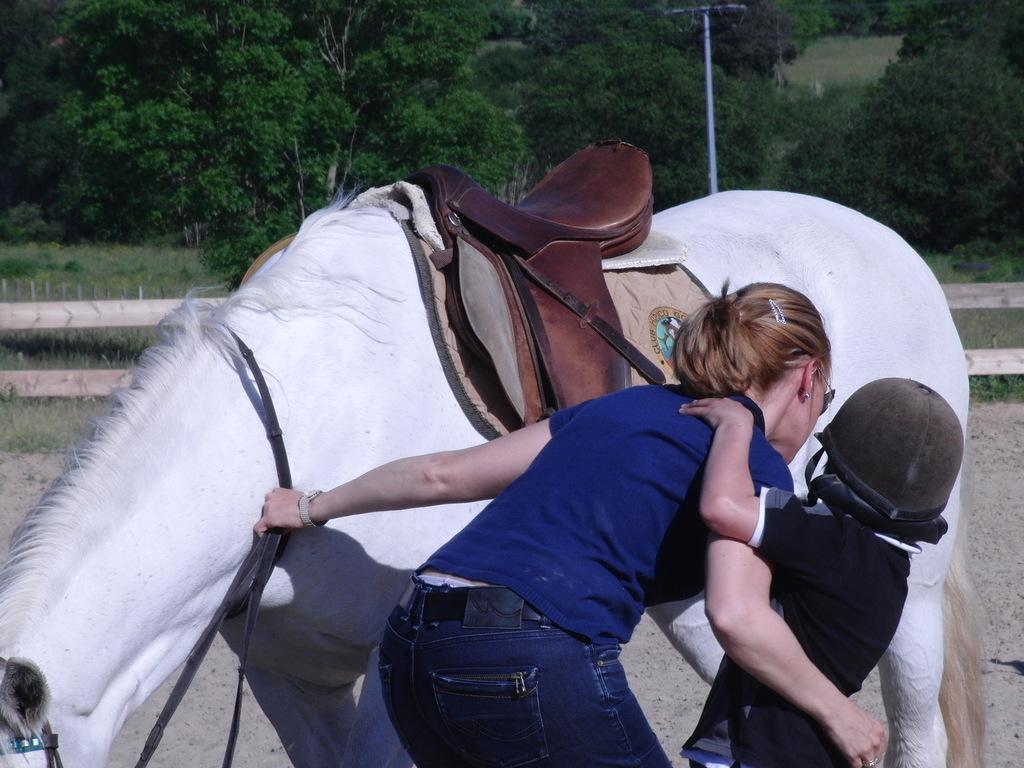In one or two sentences, can you explain what this image depicts? In this image there is a white horse. Beside it there is a woman and a kid. The woman is wearing a blue t-shirt. The kid is wearing a helmet. In the background there are trees. 